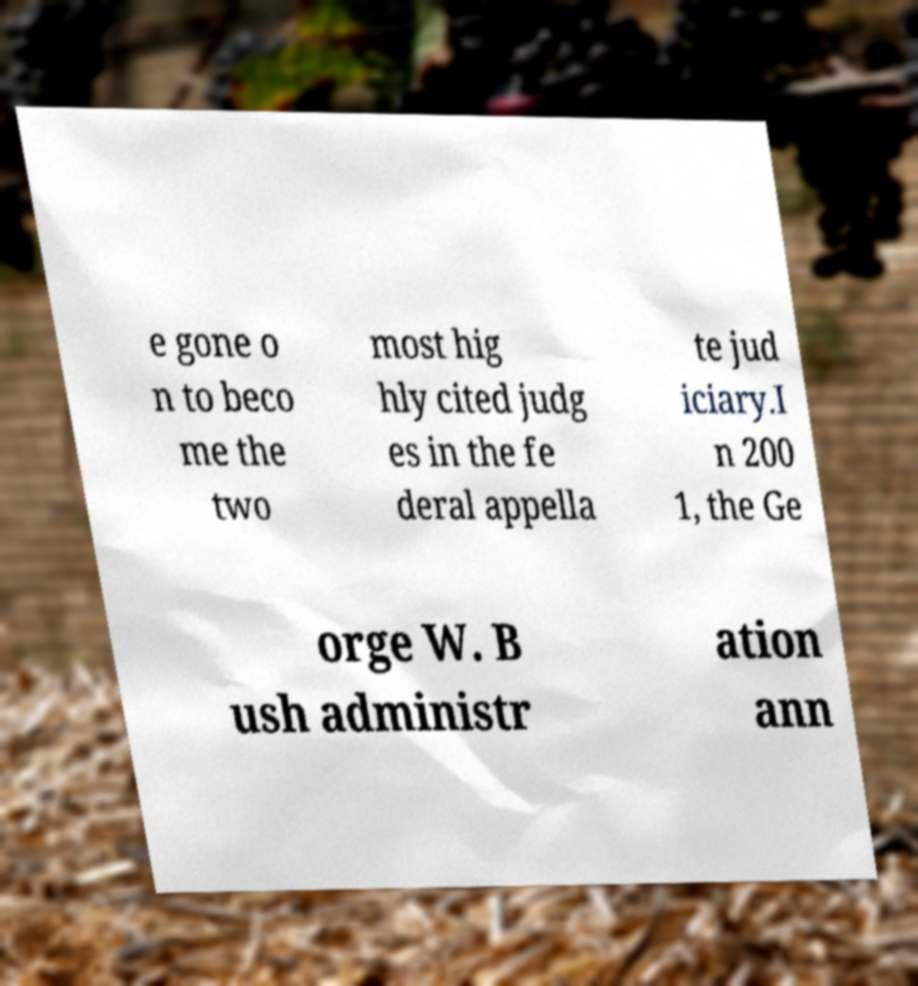There's text embedded in this image that I need extracted. Can you transcribe it verbatim? e gone o n to beco me the two most hig hly cited judg es in the fe deral appella te jud iciary.I n 200 1, the Ge orge W. B ush administr ation ann 